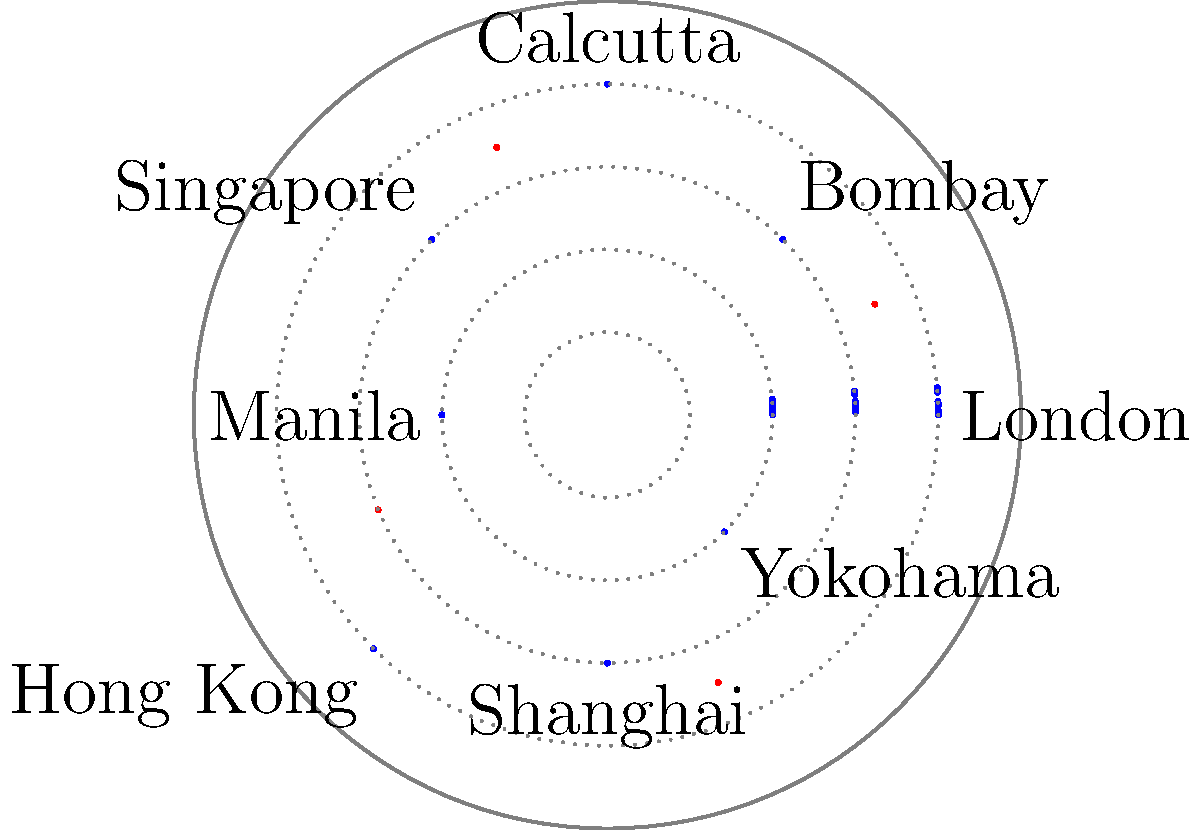In the polar coordinate map representing colonial trade routes (blue) and indigenous resistance hotspots (red), which quadrant contains the highest concentration of resistance activity relative to trade route density? To answer this question, we need to analyze the distribution of trade routes and resistance hotspots in each quadrant of the polar coordinate map. Let's break it down step-by-step:

1. Divide the map into four quadrants:
   - Q1: 0° to 90° (Northeast)
   - Q2: 90° to 180° (Northwest)
   - Q3: 180° to 270° (Southwest)
   - Q4: 270° to 360° (Southeast)

2. Analyze each quadrant:

   Q1 (Northeast):
   - Trade routes: 2 (London to Bombay, Bombay to Calcutta)
   - Resistance hotspot: 1 (Arabian Sea)
   - Ratio: 1 resistance point per 2 trade routes

   Q2 (Northwest):
   - Trade routes: 2 (Calcutta to Singapore, Singapore to Manila)
   - Resistance hotspot: 1 (Bay of Bengal)
   - Ratio: 1 resistance point per 2 trade routes

   Q3 (Southwest):
   - Trade routes: 2 (Manila to Hong Kong, Hong Kong to Shanghai)
   - Resistance hotspot: 1 (South China Sea)
   - Ratio: 1 resistance point per 2 trade routes

   Q4 (Southeast):
   - Trade routes: 2 (Shanghai to Yokohama, Yokohama to London)
   - Resistance hotspot: 1 (East China Sea)
   - Ratio: 1 resistance point per 2 trade routes

3. Compare the ratios:
   All quadrants have the same ratio of 1 resistance point per 2 trade routes.

4. Consider the intensity:
   The resistance hotspot in Q4 (East China Sea) appears to be slightly larger or more intense than the others, suggesting a higher concentration of resistance activity relative to trade route density in this quadrant.
Answer: Southeast quadrant (Q4) 